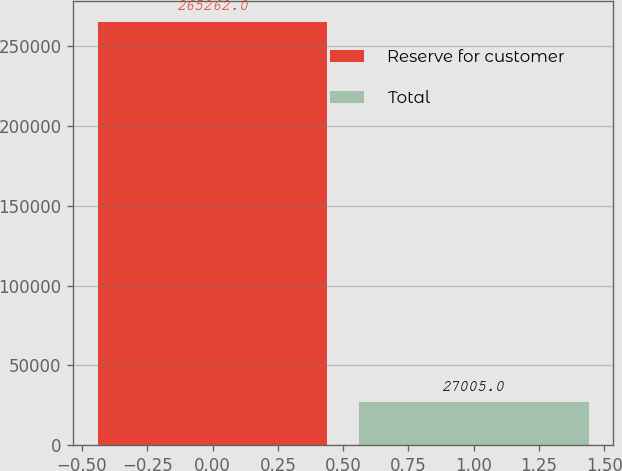Convert chart to OTSL. <chart><loc_0><loc_0><loc_500><loc_500><bar_chart><fcel>Reserve for customer<fcel>Total<nl><fcel>265262<fcel>27005<nl></chart> 